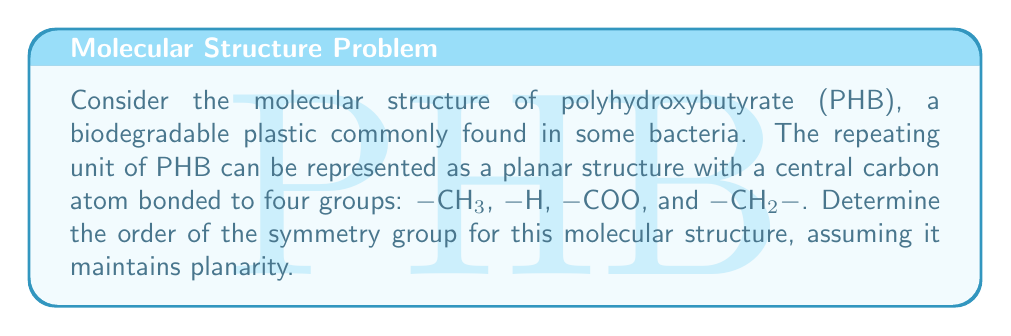Teach me how to tackle this problem. To analyze the symmetry group of the PHB repeating unit, we need to consider its molecular structure and identify the symmetry operations that leave it unchanged. Let's approach this step-by-step:

1. Visualize the structure:
   The central carbon atom is bonded to four different groups (-CH3, -H, -COO, and -CH2-) in a planar arrangement.

2. Identify possible symmetry operations:
   a) Rotations: Due to the four different substituents, there are no rotational symmetries.
   b) Reflections: There is no plane of reflection that leaves the molecule unchanged.
   c) Identity: The identity operation always leaves the molecule unchanged.

3. Count the symmetry operations:
   We have only one symmetry operation: the identity operation.

4. Determine the order of the symmetry group:
   The order of a group is the number of elements in the group. In this case, we have only one element (the identity operation).

5. Identify the group:
   This symmetry group with only the identity element is isomorphic to the cyclic group of order 1, denoted as $C_1$ or $\mathbb{Z}_1$.

The order of the symmetry group is therefore 1.

This low symmetry is typical for many biodegradable plastics, as their complex structures often lack high degrees of symmetry. This asymmetry can contribute to their biodegradability, as it may make the molecules more susceptible to enzymatic breakdown.
Answer: The order of the symmetry group for the planar molecular structure of the PHB repeating unit is 1. 